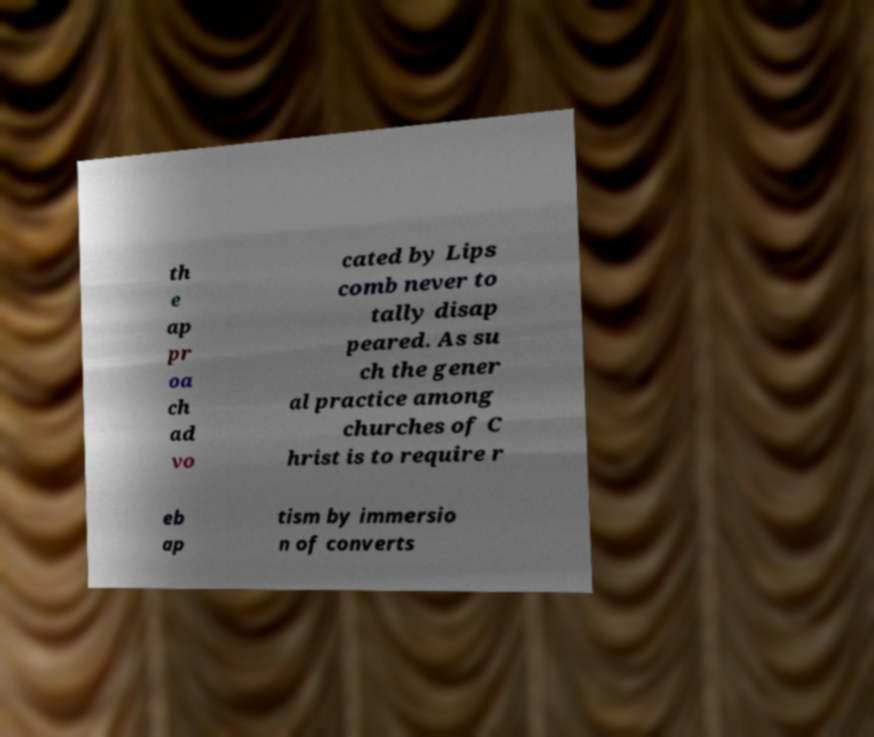Could you extract and type out the text from this image? th e ap pr oa ch ad vo cated by Lips comb never to tally disap peared. As su ch the gener al practice among churches of C hrist is to require r eb ap tism by immersio n of converts 